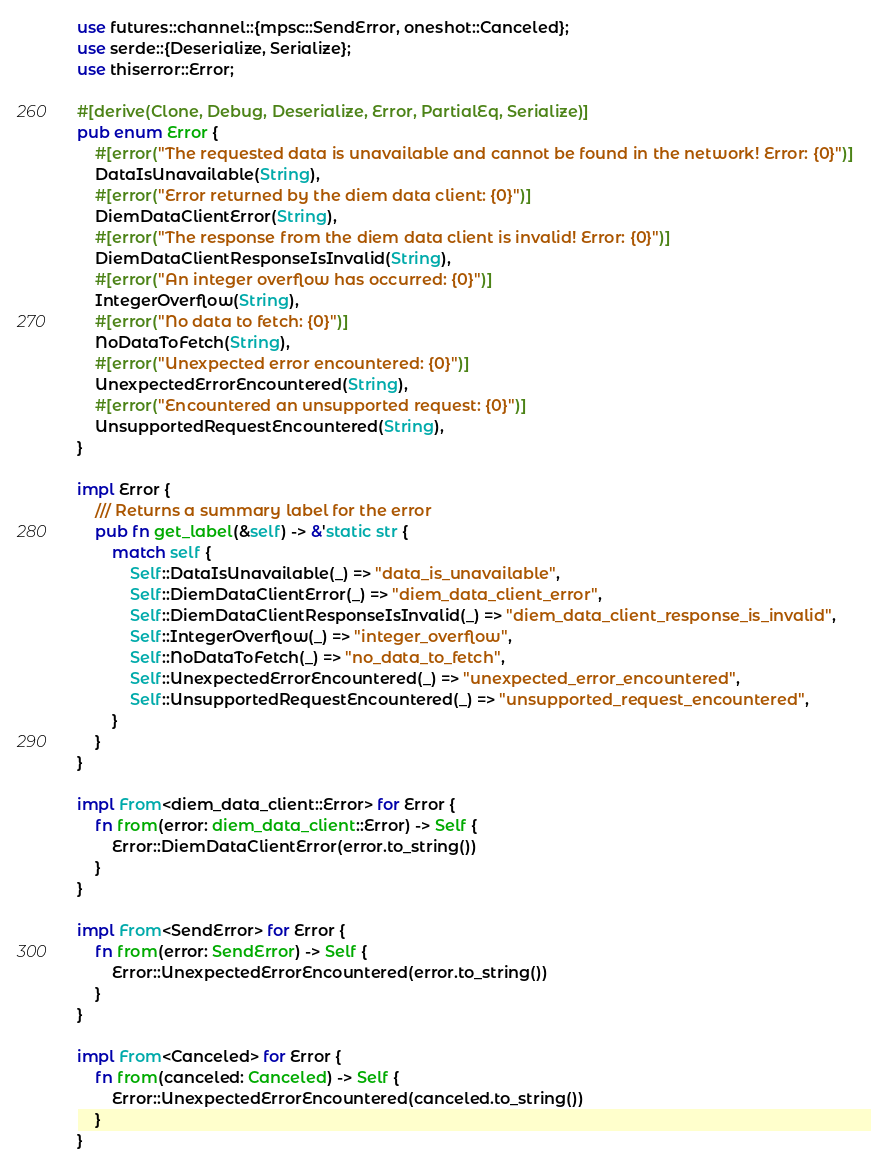<code> <loc_0><loc_0><loc_500><loc_500><_Rust_>use futures::channel::{mpsc::SendError, oneshot::Canceled};
use serde::{Deserialize, Serialize};
use thiserror::Error;

#[derive(Clone, Debug, Deserialize, Error, PartialEq, Serialize)]
pub enum Error {
    #[error("The requested data is unavailable and cannot be found in the network! Error: {0}")]
    DataIsUnavailable(String),
    #[error("Error returned by the diem data client: {0}")]
    DiemDataClientError(String),
    #[error("The response from the diem data client is invalid! Error: {0}")]
    DiemDataClientResponseIsInvalid(String),
    #[error("An integer overflow has occurred: {0}")]
    IntegerOverflow(String),
    #[error("No data to fetch: {0}")]
    NoDataToFetch(String),
    #[error("Unexpected error encountered: {0}")]
    UnexpectedErrorEncountered(String),
    #[error("Encountered an unsupported request: {0}")]
    UnsupportedRequestEncountered(String),
}

impl Error {
    /// Returns a summary label for the error
    pub fn get_label(&self) -> &'static str {
        match self {
            Self::DataIsUnavailable(_) => "data_is_unavailable",
            Self::DiemDataClientError(_) => "diem_data_client_error",
            Self::DiemDataClientResponseIsInvalid(_) => "diem_data_client_response_is_invalid",
            Self::IntegerOverflow(_) => "integer_overflow",
            Self::NoDataToFetch(_) => "no_data_to_fetch",
            Self::UnexpectedErrorEncountered(_) => "unexpected_error_encountered",
            Self::UnsupportedRequestEncountered(_) => "unsupported_request_encountered",
        }
    }
}

impl From<diem_data_client::Error> for Error {
    fn from(error: diem_data_client::Error) -> Self {
        Error::DiemDataClientError(error.to_string())
    }
}

impl From<SendError> for Error {
    fn from(error: SendError) -> Self {
        Error::UnexpectedErrorEncountered(error.to_string())
    }
}

impl From<Canceled> for Error {
    fn from(canceled: Canceled) -> Self {
        Error::UnexpectedErrorEncountered(canceled.to_string())
    }
}
</code> 